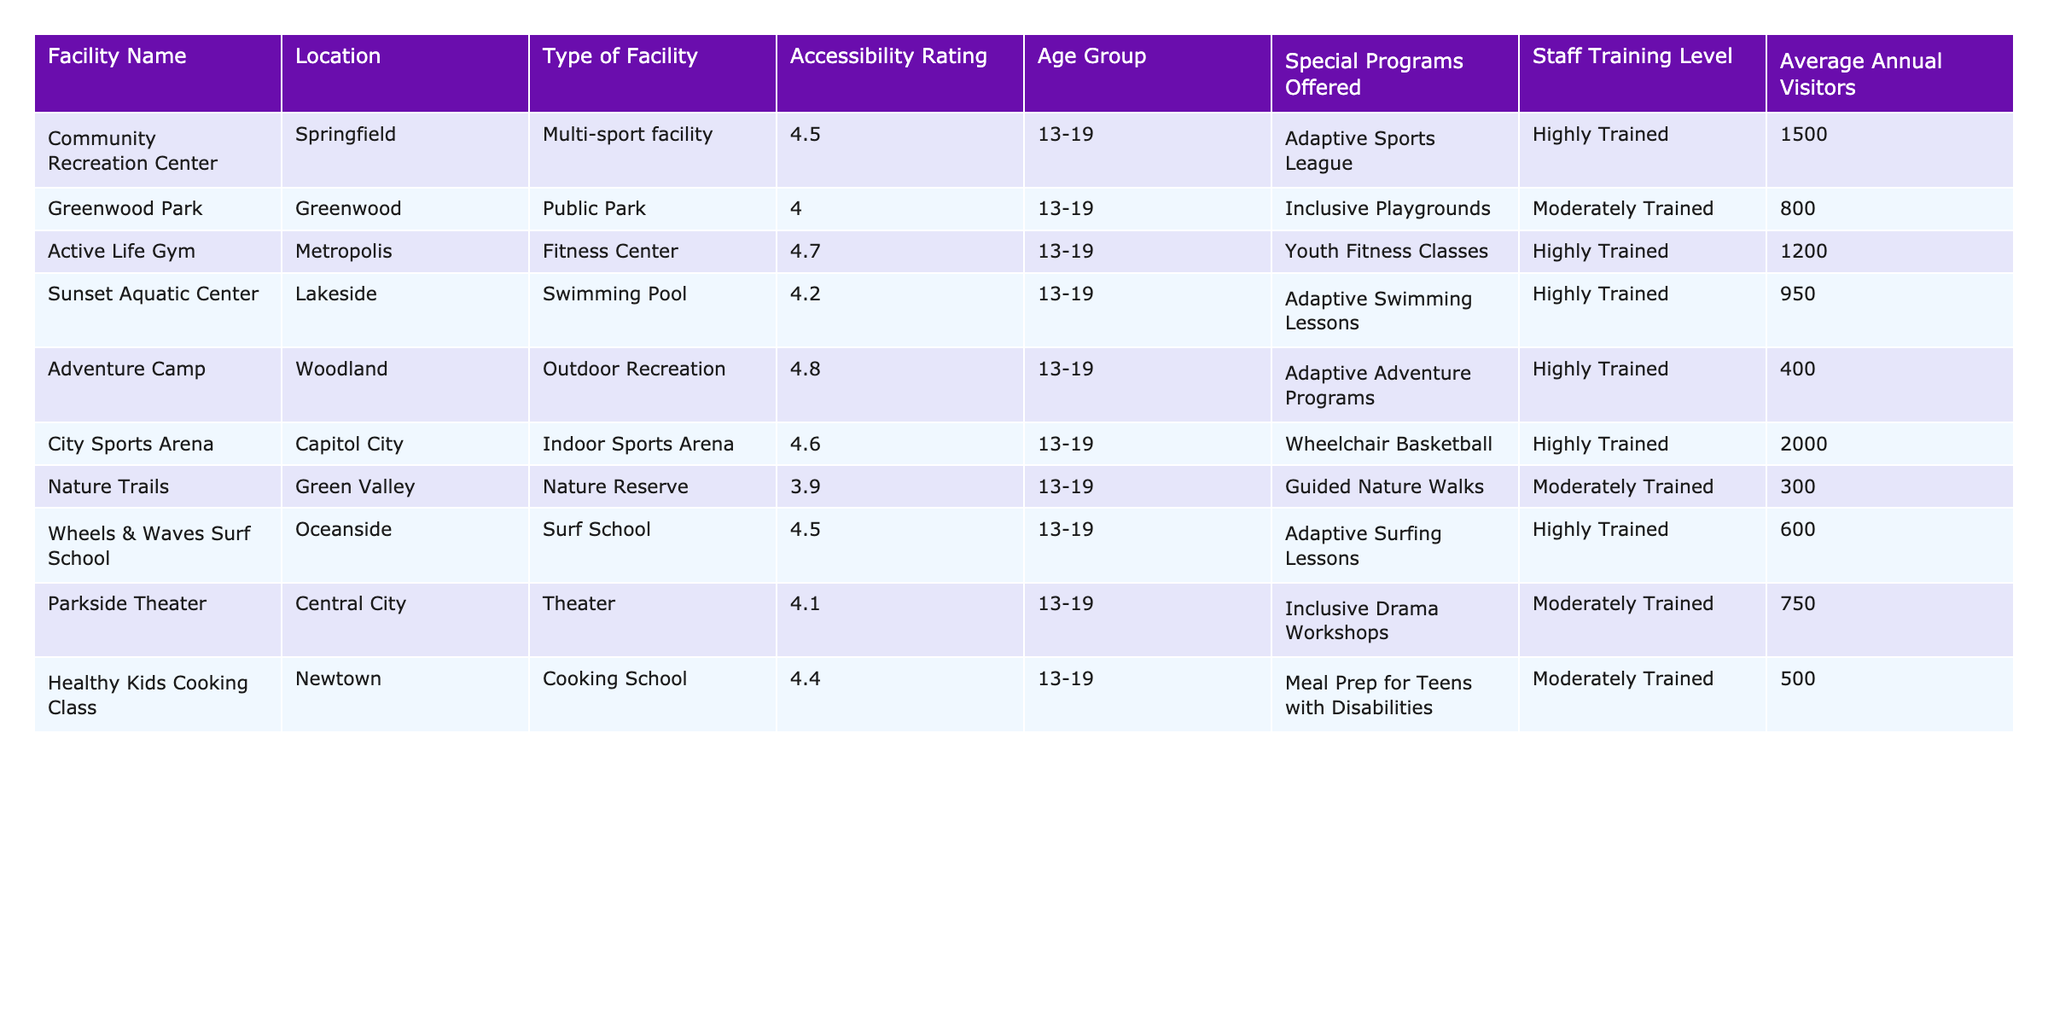What is the accessibility rating of the Active Life Gym? The table shows that the accessibility rating for Active Life Gym is 4.7.
Answer: 4.7 Which facility has the highest average annual visitors? By looking at the average annual visitors column, City Sports Arena has the highest number with 2000 visitors.
Answer: City Sports Arena Are all the facilities in the table trained staff? The table lists different training levels; some facilities have "Highly Trained" staff, while others have "Moderately Trained." Therefore, not all facilities have trained staff.
Answer: No What is the total number of average annual visitors for all facilities combined? To find the total, we sum the average visitors: 1500 + 800 + 1200 + 950 + 400 + 2000 + 300 + 600 + 750 + 500 = 10000.
Answer: 10000 Which facility located in Lakeside offers special programs? According to the table, the Sunset Aquatic Center is located in Lakeside and offers adaptive swimming lessons.
Answer: Sunset Aquatic Center How many facilities have an accessibility rating of 4.5 or higher? The facilities that meet this criterion are Community Recreation Center, Active Life Gym, City Sports Arena, and Wheels & Waves Surf School. Therefore, there are four facilities.
Answer: 4 Is there a facility that offers both adaptive programs and has a high accessibility rating? The Adventure Camp, with a rating of 4.8, offers adaptive adventure programs, fulfilling both conditions.
Answer: Yes What is the average accessibility rating of the facilities located in Greenwood and Lakeside? The accessibility ratings for Greenwood Park (4.0) and Sunset Aquatic Center (4.2) need to be averaged: (4.0 + 4.2) / 2 = 4.1.
Answer: 4.1 Which facility offers inclusive drama workshops and what is its accessibility rating? The Parkside Theater offers inclusive drama workshops and has an accessibility rating of 4.1.
Answer: Parkside Theater, 4.1 How many facilities offer special programs related to sports? The facilities offering sports-related programs are Active Life Gym (youth fitness), City Sports Arena (wheelchair basketball), and Adventure Camp (adaptive adventure), totaling three facilities.
Answer: 3 